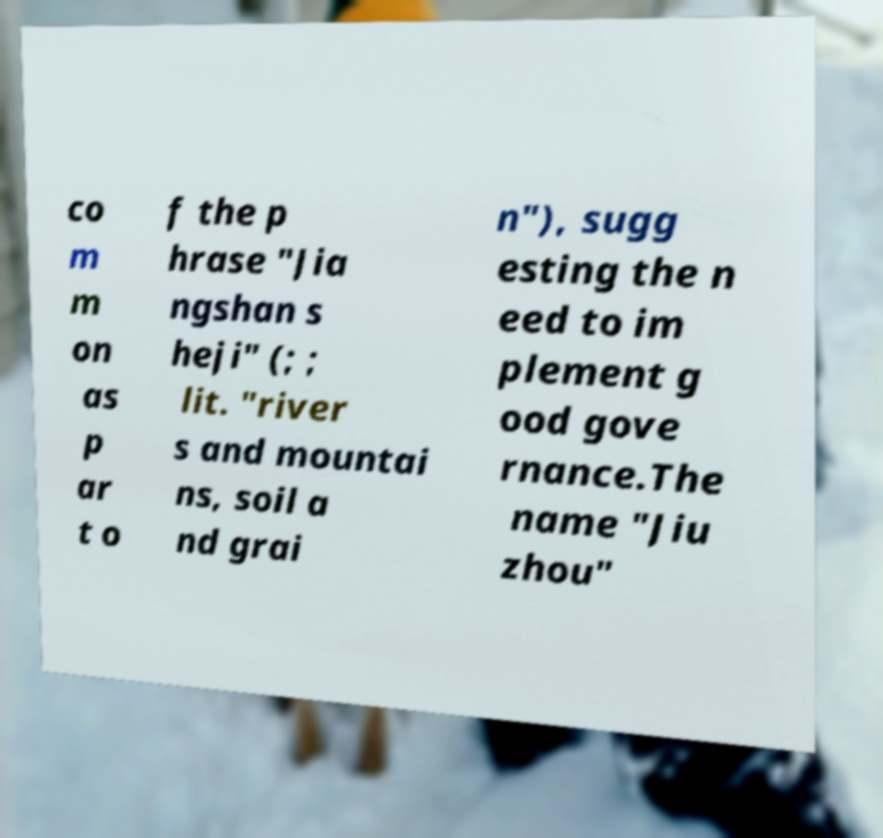Could you assist in decoding the text presented in this image and type it out clearly? co m m on as p ar t o f the p hrase "Jia ngshan s heji" (; ; lit. "river s and mountai ns, soil a nd grai n"), sugg esting the n eed to im plement g ood gove rnance.The name "Jiu zhou" 